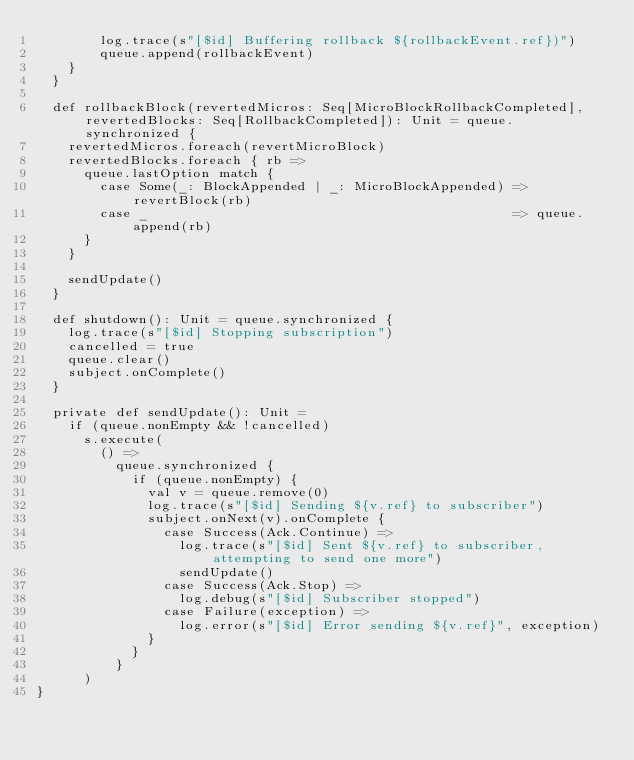Convert code to text. <code><loc_0><loc_0><loc_500><loc_500><_Scala_>        log.trace(s"[$id] Buffering rollback ${rollbackEvent.ref})")
        queue.append(rollbackEvent)
    }
  }

  def rollbackBlock(revertedMicros: Seq[MicroBlockRollbackCompleted], revertedBlocks: Seq[RollbackCompleted]): Unit = queue.synchronized {
    revertedMicros.foreach(revertMicroBlock)
    revertedBlocks.foreach { rb =>
      queue.lastOption match {
        case Some(_: BlockAppended | _: MicroBlockAppended) => revertBlock(rb)
        case _                                              => queue.append(rb)
      }
    }

    sendUpdate()
  }

  def shutdown(): Unit = queue.synchronized {
    log.trace(s"[$id] Stopping subscription")
    cancelled = true
    queue.clear()
    subject.onComplete()
  }

  private def sendUpdate(): Unit =
    if (queue.nonEmpty && !cancelled)
      s.execute(
        () =>
          queue.synchronized {
            if (queue.nonEmpty) {
              val v = queue.remove(0)
              log.trace(s"[$id] Sending ${v.ref} to subscriber")
              subject.onNext(v).onComplete {
                case Success(Ack.Continue) =>
                  log.trace(s"[$id] Sent ${v.ref} to subscriber, attempting to send one more")
                  sendUpdate()
                case Success(Ack.Stop) =>
                  log.debug(s"[$id] Subscriber stopped")
                case Failure(exception) =>
                  log.error(s"[$id] Error sending ${v.ref}", exception)
              }
            }
          }
      )
}
</code> 